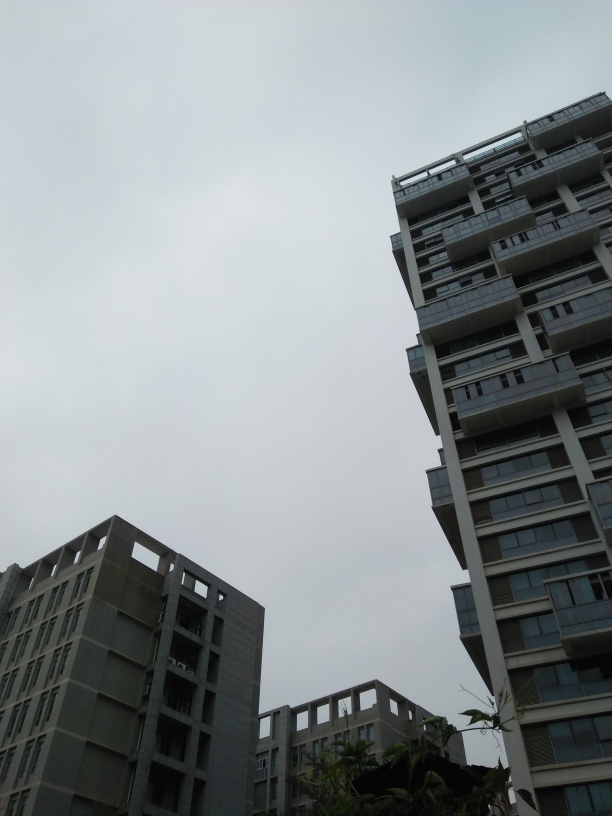What time of day and what's the weather like in this image? It appears to be daytime with an overcast sky, which suggests cloudy weather. The lack of shadows indicates the sun is obscured, making it difficult to pinpoint the exact time of day. However, the ambient light suggests it could be late morning or early afternoon. 